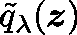Convert formula to latex. <formula><loc_0><loc_0><loc_500><loc_500>\tilde { q } _ { \lambda } ( z )</formula> 